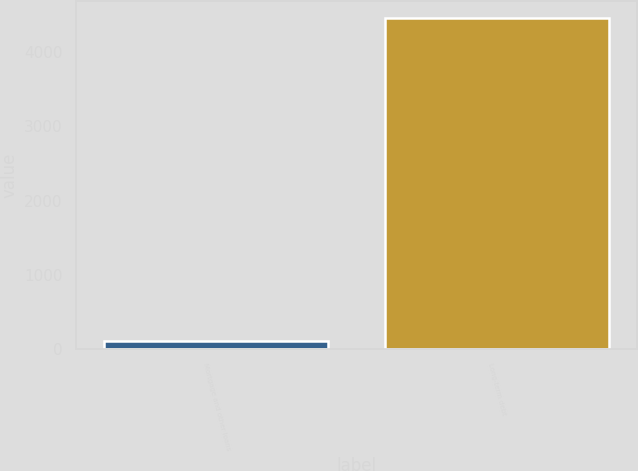Convert chart. <chart><loc_0><loc_0><loc_500><loc_500><bar_chart><fcel>Mortgage and other loans<fcel>Long-term debt<nl><fcel>113<fcel>4458<nl></chart> 